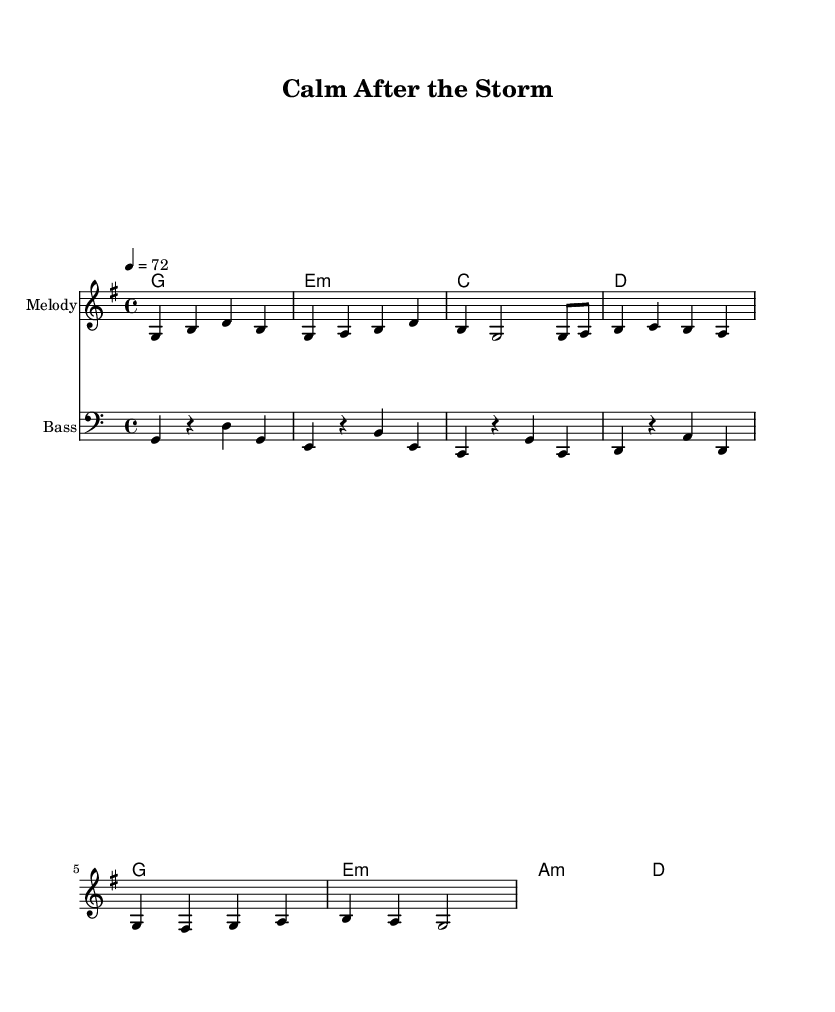What is the key signature of this music? The key signature is G major, which has one sharp (F#). This can be identified from the global section where the key is clearly defined.
Answer: G major What is the time signature of this piece? The time signature is 4/4, indicated in the global section. This signifies that there are four beats in each measure and a quarter note receives one beat.
Answer: 4/4 What is the tempo marking indicated for the piece? The tempo marking shows that the piece should play at a speed of 72 beats per minute, as specified in the global section.
Answer: 72 How many measures are there in the melody? The melody consists of 8 measures, which can be counted by looking at the melody section and identifying the number of bar lines.
Answer: 8 Which chord appears most frequently in the harmonies? The chord G major appears the most frequently in the harmonies, specifically appearing three times throughout the chord sequence.
Answer: G What is the role of the bass in this reggae piece? The bass provides a rhythmic foundation and complements the harmonies while also emphasizing the roots of the chords, which is characteristic of reggae music. This role can be inferred from the bass line that aligns with the harmony changes.
Answer: Rhythmic foundation What mood does the overall piece convey? The overall piece conveys a laid-back and relaxing mood, which is typical of reggae music, especially suited for unwinding after stress, as evident from the slow tempo and melodic flow.
Answer: Relaxed 